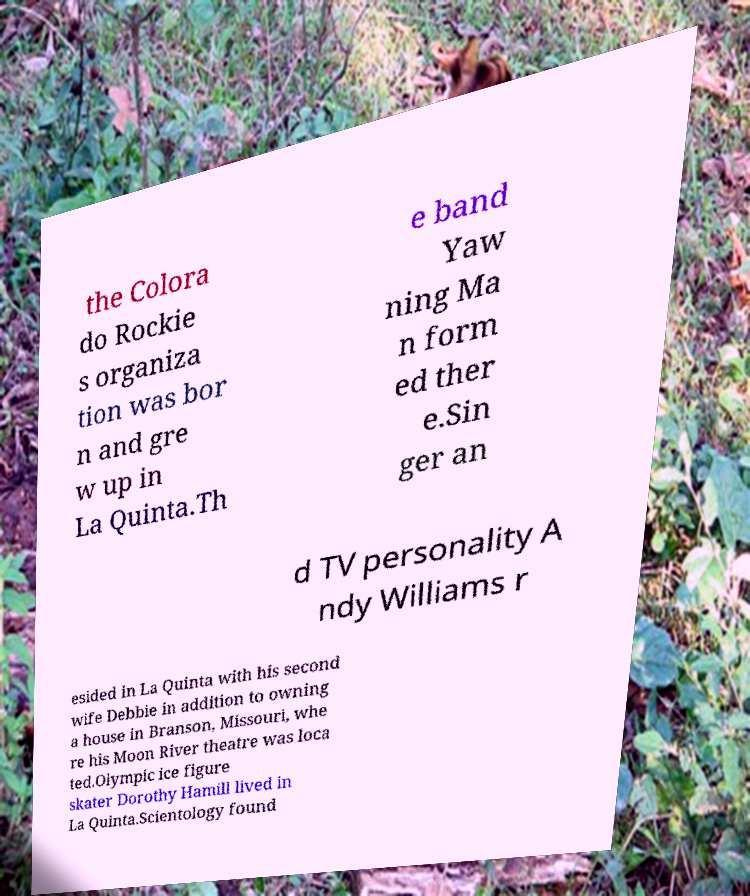For documentation purposes, I need the text within this image transcribed. Could you provide that? the Colora do Rockie s organiza tion was bor n and gre w up in La Quinta.Th e band Yaw ning Ma n form ed ther e.Sin ger an d TV personality A ndy Williams r esided in La Quinta with his second wife Debbie in addition to owning a house in Branson, Missouri, whe re his Moon River theatre was loca ted.Olympic ice figure skater Dorothy Hamill lived in La Quinta.Scientology found 